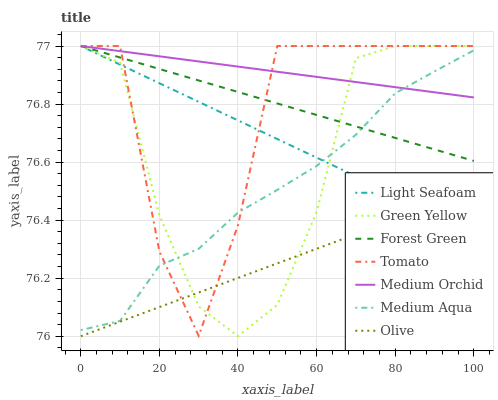Does Light Seafoam have the minimum area under the curve?
Answer yes or no. No. Does Light Seafoam have the maximum area under the curve?
Answer yes or no. No. Is Light Seafoam the smoothest?
Answer yes or no. No. Is Light Seafoam the roughest?
Answer yes or no. No. Does Light Seafoam have the lowest value?
Answer yes or no. No. Does Medium Aqua have the highest value?
Answer yes or no. No. Is Olive less than Forest Green?
Answer yes or no. Yes. Is Medium Aqua greater than Olive?
Answer yes or no. Yes. Does Olive intersect Forest Green?
Answer yes or no. No. 